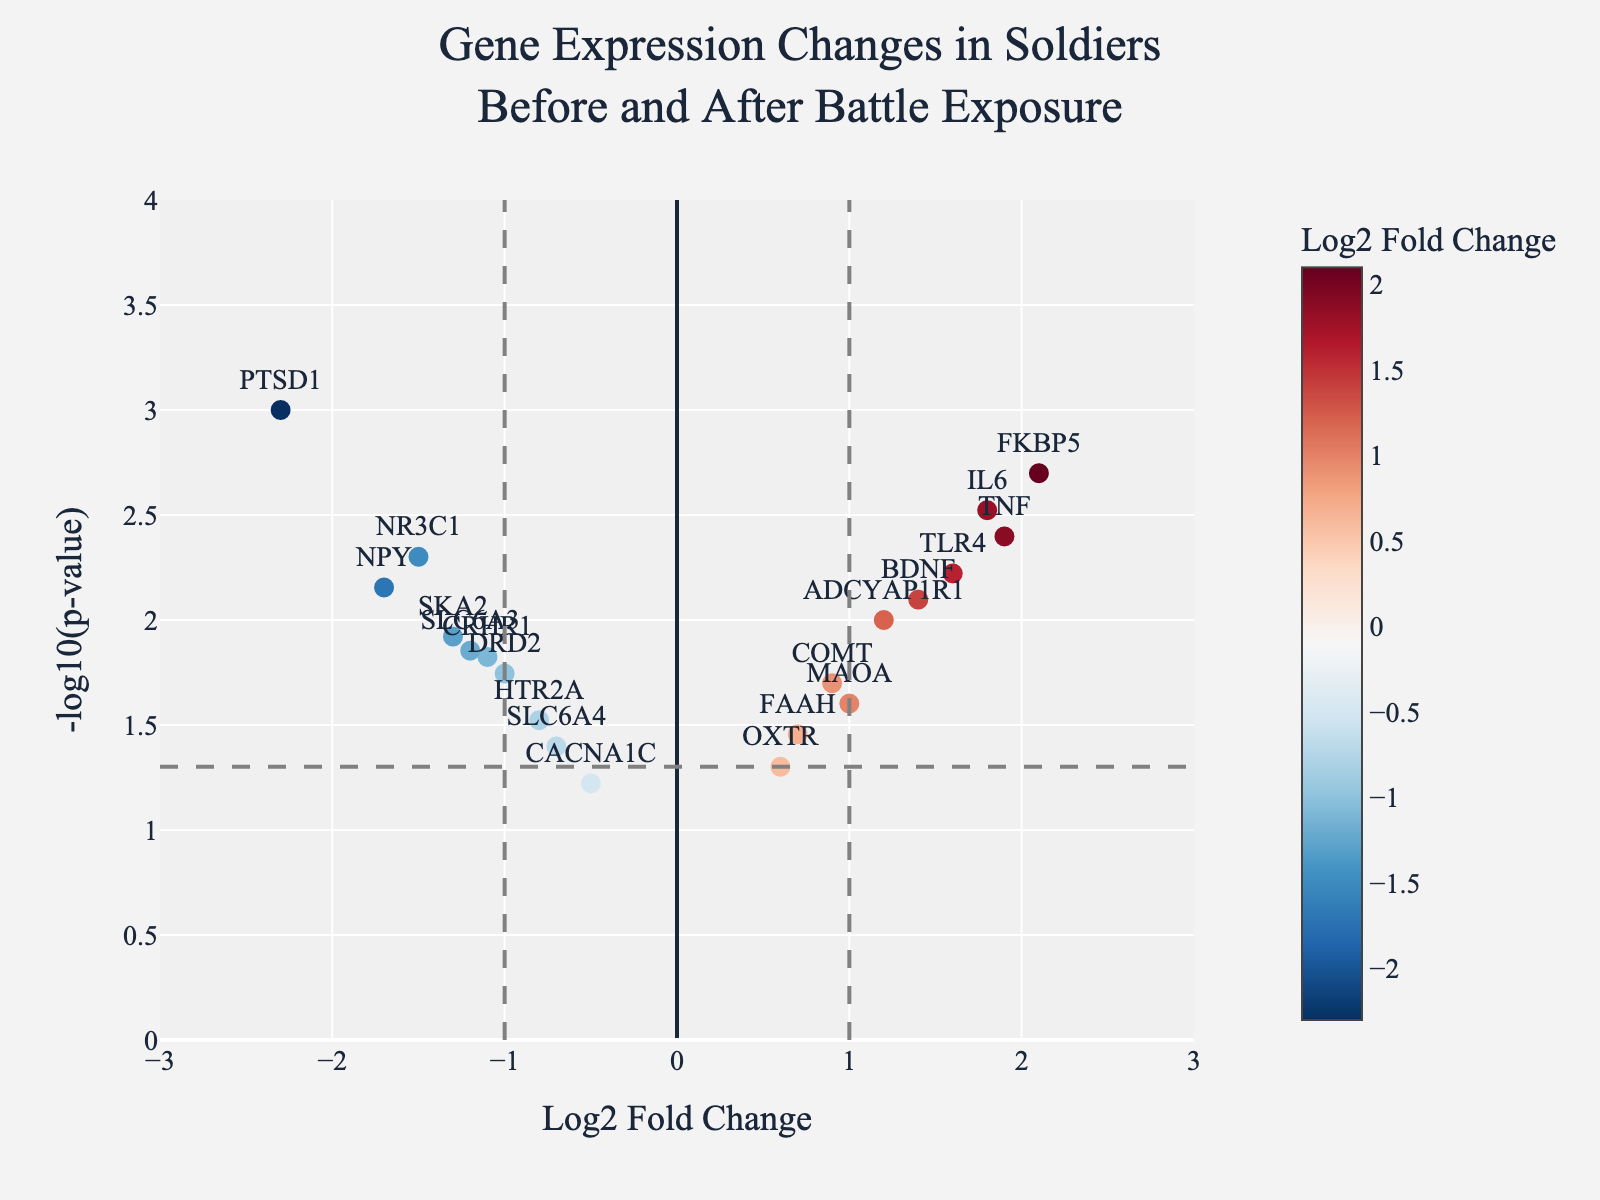What's the title of the figure? The title is generally positioned at the top of the figure. In this case, it can be found in large, bold text at the top.
Answer: Gene Expression Changes in Soldiers Before and After Battle Exposure What are the ranges of the x-axis and y-axis? Typically, the x-axis range is horizontally displayed at the bottom, and the y-axis range is vertically displayed on the side. Here, the x-axis ranges from -3 to 3, and the y-axis ranges from 0 to 4.
Answer: x-axis: -3 to 3, y-axis: 0 to 4 Which gene has the highest Log2 Fold Change? To identify the gene with the highest Log2 Fold Change, find the marker farthest to the right on the x-axis. The label or hover text will tell you the gene.
Answer: FKBP5 Which gene has the lowest p-value (highest -log10(p))? Identify the highest point on the y-axis since -log10(p) increases as p decreases. Look for the label or hover text of this point.
Answer: PTSD1 Are there any genes with a Log2 Fold Change between -1 and 1 and a p-value greater than 0.05? Check genes within -1 to 1 on the x-axis. The horizontal line at y ≈ 1.3 represents a p-value of 0.05 (since -log10(0.05) ≈ 1.3). Find genes below this line in the mentioned x-axis range.
Answer: No How many genes have a Log2 Fold Change greater than 1 and a p-value less than 0.005? Within the x-axis range greater than 1, count points above y ≈ 2.3 (since -log10(0.005) ≈ 2.3).
Answer: 3 Which gene is positioned closely to the origin (0,0)? Locate the point nearest to (0,0) in the plot by examining the coordinates. The label or hover text will indicate the gene name.
Answer: OXTR Which genes are differentially expressed with a p-value less than 0.01 and Log2 Fold Change outside the range -1 to 1? Examine points outside the vertical lines at -1 and 1 and above the horizontal line at y ≈ 2. These points represent genes with significant expression changes.
Answer: PTSD1, IL6, FKBP5, NPY, TLR4, TNF What's the average Log2 Fold Change of the genes? Sum the Log2 Fold Change values of all genes and divide by the number of genes. Sum=(-2.3 + 1.8 + 0.9 - 1.5 + 2.1 - 0.7 + 1.2 - 1.1 + 0.6 - 1.7 + 1.4 - 0.8 + 1.0 - 1.3 + 1.6 - 0.5 + 1.9 - 1.0 + 0.7 - 1.2) = 1.5. Number of genes=20. 1.5 / 20 ≈ 0.075
Answer: 0.075 